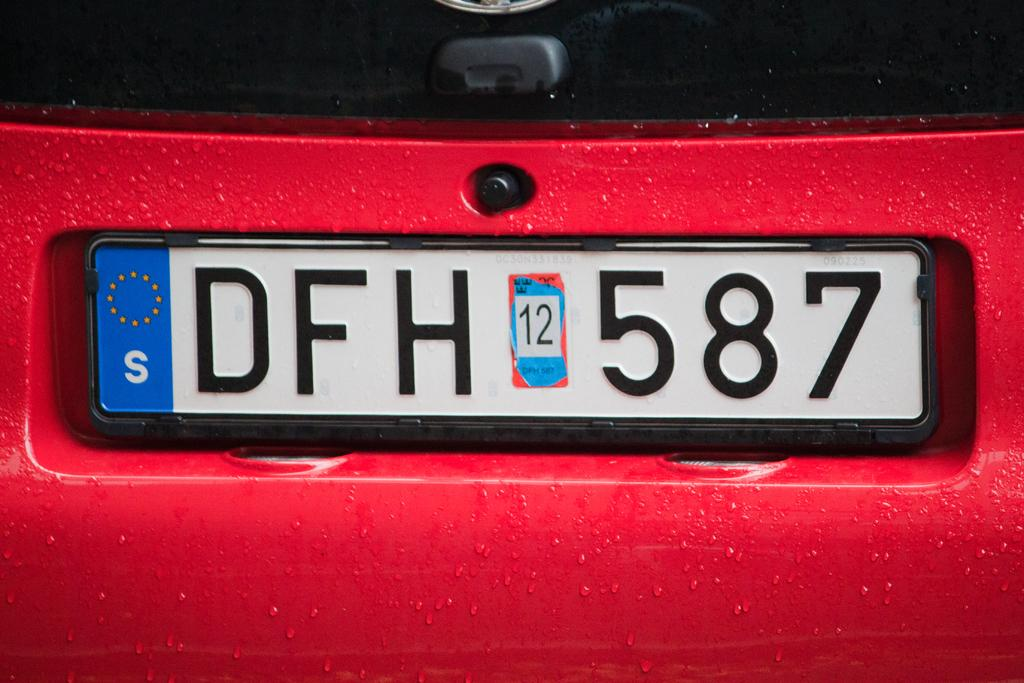<image>
Relay a brief, clear account of the picture shown. A Swedish license plate with DFH 587 is attached to a wet, red car 